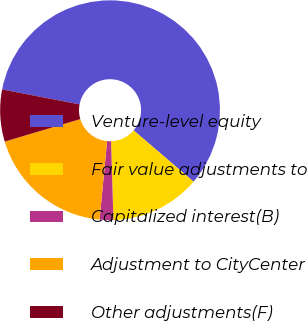Convert chart. <chart><loc_0><loc_0><loc_500><loc_500><pie_chart><fcel>Venture-level equity<fcel>Fair value adjustments to<fcel>Capitalized interest(B)<fcel>Adjustment to CityCenter<fcel>Other adjustments(F)<nl><fcel>58.24%<fcel>13.25%<fcel>2.01%<fcel>18.88%<fcel>7.63%<nl></chart> 